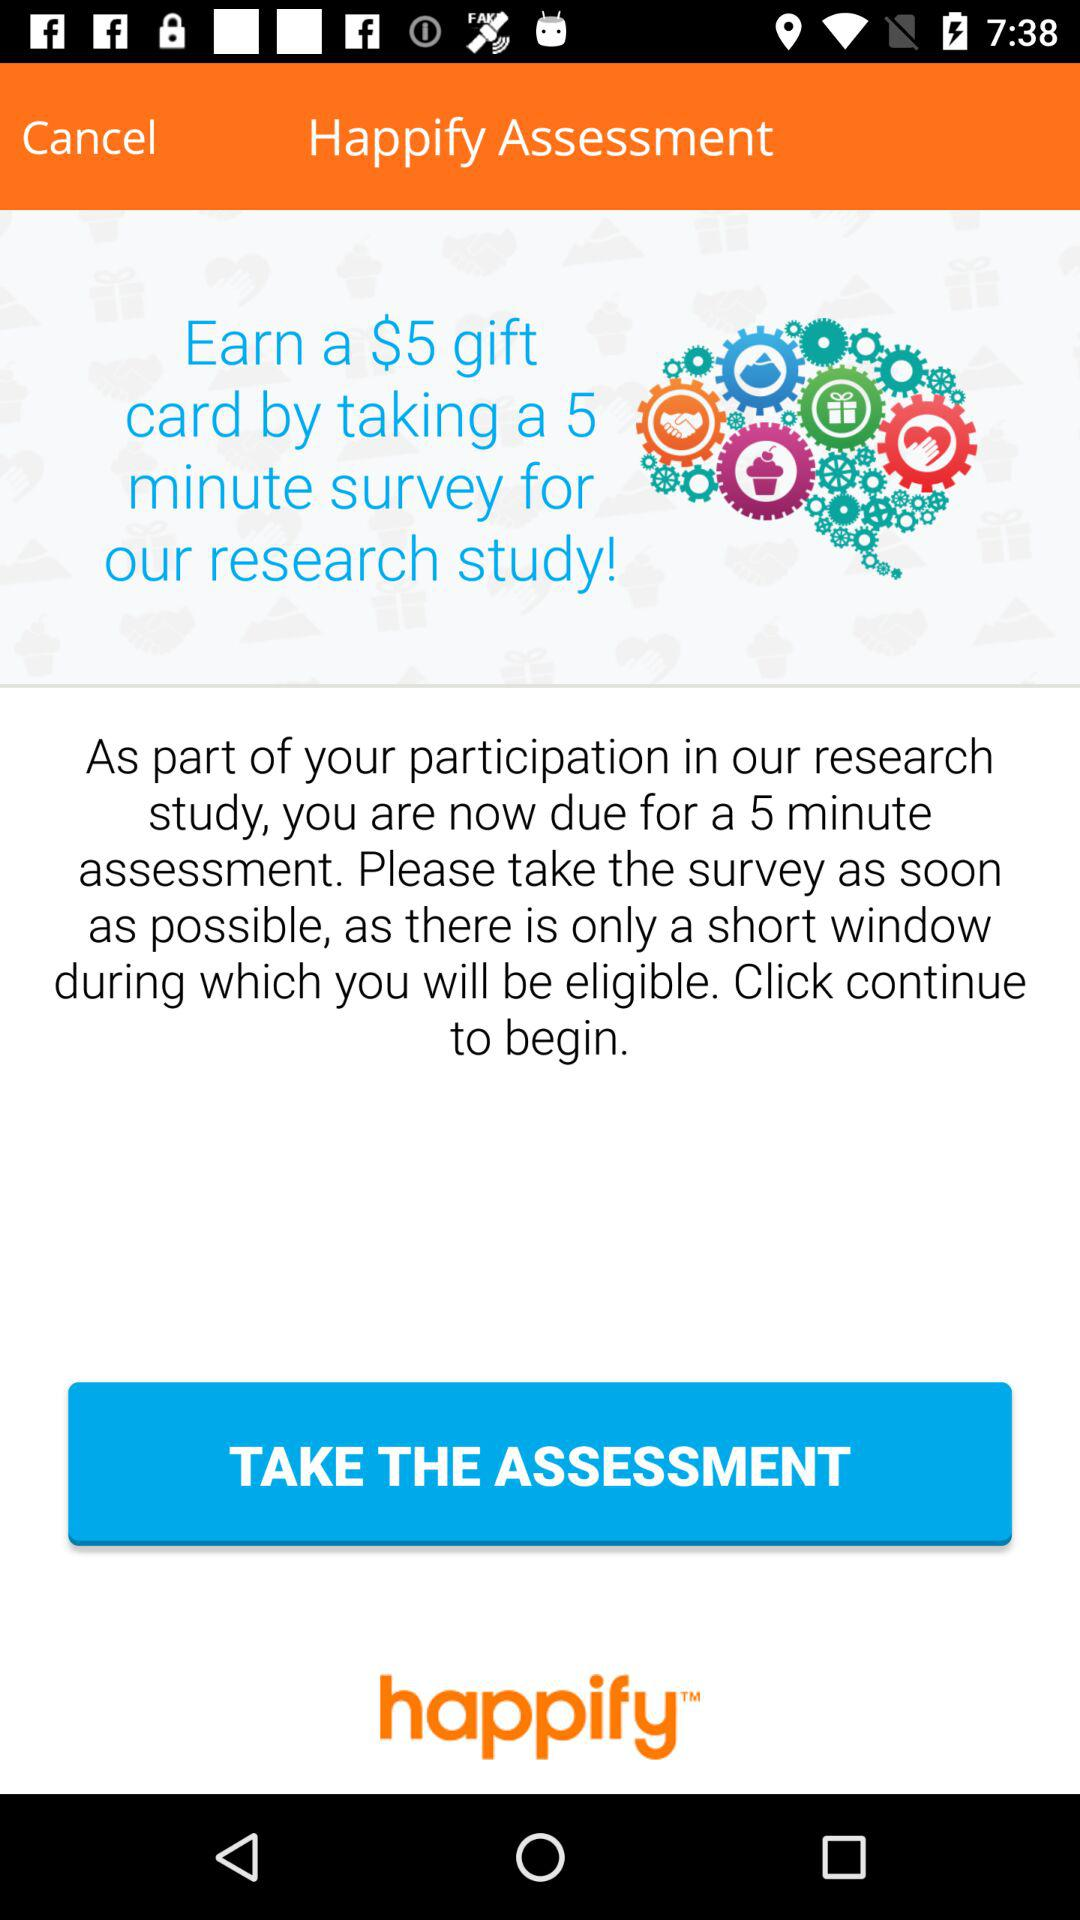How many questions are in the 5 minute assessment?
When the provided information is insufficient, respond with <no answer>. <no answer> 